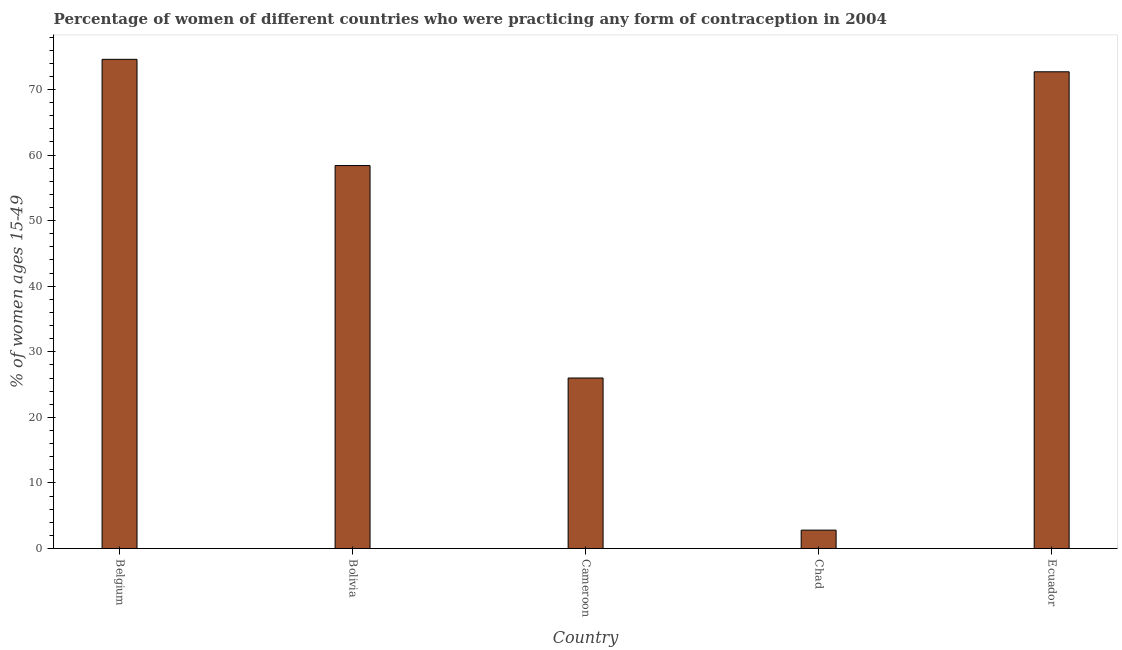Does the graph contain any zero values?
Ensure brevity in your answer.  No. Does the graph contain grids?
Offer a very short reply. No. What is the title of the graph?
Your answer should be very brief. Percentage of women of different countries who were practicing any form of contraception in 2004. What is the label or title of the X-axis?
Give a very brief answer. Country. What is the label or title of the Y-axis?
Give a very brief answer. % of women ages 15-49. What is the contraceptive prevalence in Ecuador?
Your answer should be very brief. 72.7. Across all countries, what is the maximum contraceptive prevalence?
Give a very brief answer. 74.6. In which country was the contraceptive prevalence minimum?
Give a very brief answer. Chad. What is the sum of the contraceptive prevalence?
Offer a very short reply. 234.5. What is the difference between the contraceptive prevalence in Chad and Ecuador?
Keep it short and to the point. -69.9. What is the average contraceptive prevalence per country?
Ensure brevity in your answer.  46.9. What is the median contraceptive prevalence?
Give a very brief answer. 58.4. Is the contraceptive prevalence in Belgium less than that in Ecuador?
Ensure brevity in your answer.  No. Is the sum of the contraceptive prevalence in Belgium and Chad greater than the maximum contraceptive prevalence across all countries?
Your response must be concise. Yes. What is the difference between the highest and the lowest contraceptive prevalence?
Offer a very short reply. 71.8. In how many countries, is the contraceptive prevalence greater than the average contraceptive prevalence taken over all countries?
Offer a terse response. 3. How many bars are there?
Make the answer very short. 5. How many countries are there in the graph?
Give a very brief answer. 5. What is the difference between two consecutive major ticks on the Y-axis?
Give a very brief answer. 10. What is the % of women ages 15-49 of Belgium?
Keep it short and to the point. 74.6. What is the % of women ages 15-49 of Bolivia?
Offer a terse response. 58.4. What is the % of women ages 15-49 of Cameroon?
Your response must be concise. 26. What is the % of women ages 15-49 in Chad?
Your answer should be compact. 2.8. What is the % of women ages 15-49 of Ecuador?
Keep it short and to the point. 72.7. What is the difference between the % of women ages 15-49 in Belgium and Cameroon?
Your answer should be compact. 48.6. What is the difference between the % of women ages 15-49 in Belgium and Chad?
Provide a succinct answer. 71.8. What is the difference between the % of women ages 15-49 in Belgium and Ecuador?
Offer a very short reply. 1.9. What is the difference between the % of women ages 15-49 in Bolivia and Cameroon?
Your response must be concise. 32.4. What is the difference between the % of women ages 15-49 in Bolivia and Chad?
Offer a terse response. 55.6. What is the difference between the % of women ages 15-49 in Bolivia and Ecuador?
Your answer should be very brief. -14.3. What is the difference between the % of women ages 15-49 in Cameroon and Chad?
Provide a short and direct response. 23.2. What is the difference between the % of women ages 15-49 in Cameroon and Ecuador?
Offer a very short reply. -46.7. What is the difference between the % of women ages 15-49 in Chad and Ecuador?
Make the answer very short. -69.9. What is the ratio of the % of women ages 15-49 in Belgium to that in Bolivia?
Make the answer very short. 1.28. What is the ratio of the % of women ages 15-49 in Belgium to that in Cameroon?
Provide a succinct answer. 2.87. What is the ratio of the % of women ages 15-49 in Belgium to that in Chad?
Ensure brevity in your answer.  26.64. What is the ratio of the % of women ages 15-49 in Bolivia to that in Cameroon?
Your response must be concise. 2.25. What is the ratio of the % of women ages 15-49 in Bolivia to that in Chad?
Make the answer very short. 20.86. What is the ratio of the % of women ages 15-49 in Bolivia to that in Ecuador?
Give a very brief answer. 0.8. What is the ratio of the % of women ages 15-49 in Cameroon to that in Chad?
Your answer should be very brief. 9.29. What is the ratio of the % of women ages 15-49 in Cameroon to that in Ecuador?
Ensure brevity in your answer.  0.36. What is the ratio of the % of women ages 15-49 in Chad to that in Ecuador?
Keep it short and to the point. 0.04. 